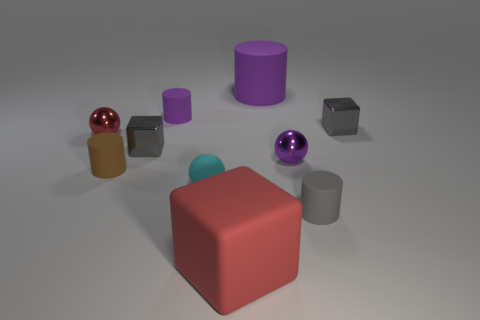There is a gray object that is behind the tiny sphere that is to the left of the tiny matte ball; what number of small blocks are in front of it?
Offer a terse response. 1. What size is the other ball that is the same material as the tiny red sphere?
Make the answer very short. Small. What number of rubber cubes are the same color as the small matte ball?
Your response must be concise. 0. There is a metal sphere that is on the left side of the cyan thing; is it the same size as the brown cylinder?
Provide a short and direct response. Yes. The tiny rubber cylinder that is left of the big rubber cylinder and right of the brown rubber thing is what color?
Your answer should be compact. Purple. What number of things are either tiny red matte balls or large rubber things behind the brown rubber cylinder?
Provide a succinct answer. 1. What is the material of the large object that is in front of the gray metallic thing that is right of the large rubber thing behind the small red sphere?
Your answer should be compact. Rubber. Is there anything else that has the same material as the tiny purple cylinder?
Your answer should be compact. Yes. There is a cylinder on the right side of the tiny purple sphere; is it the same color as the big cube?
Offer a very short reply. No. What number of red objects are either small things or small metal balls?
Ensure brevity in your answer.  1. 